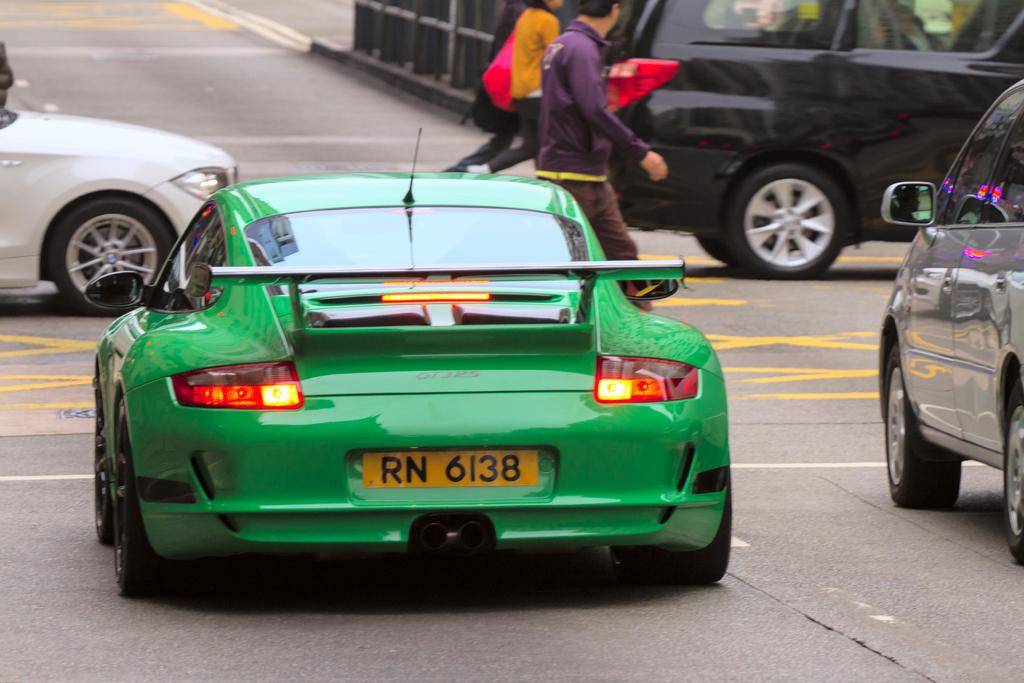What is happening on the road in the image? There are vehicles on the road and three persons walking on the road in the image. What can be seen at the back of the image? There is a railing at the back of the image. What is the primary feature at the bottom of the image? There is a road at the bottom of the image. What type of ring is being compared to the air in the image? There is no ring or comparison to air present in the image. 